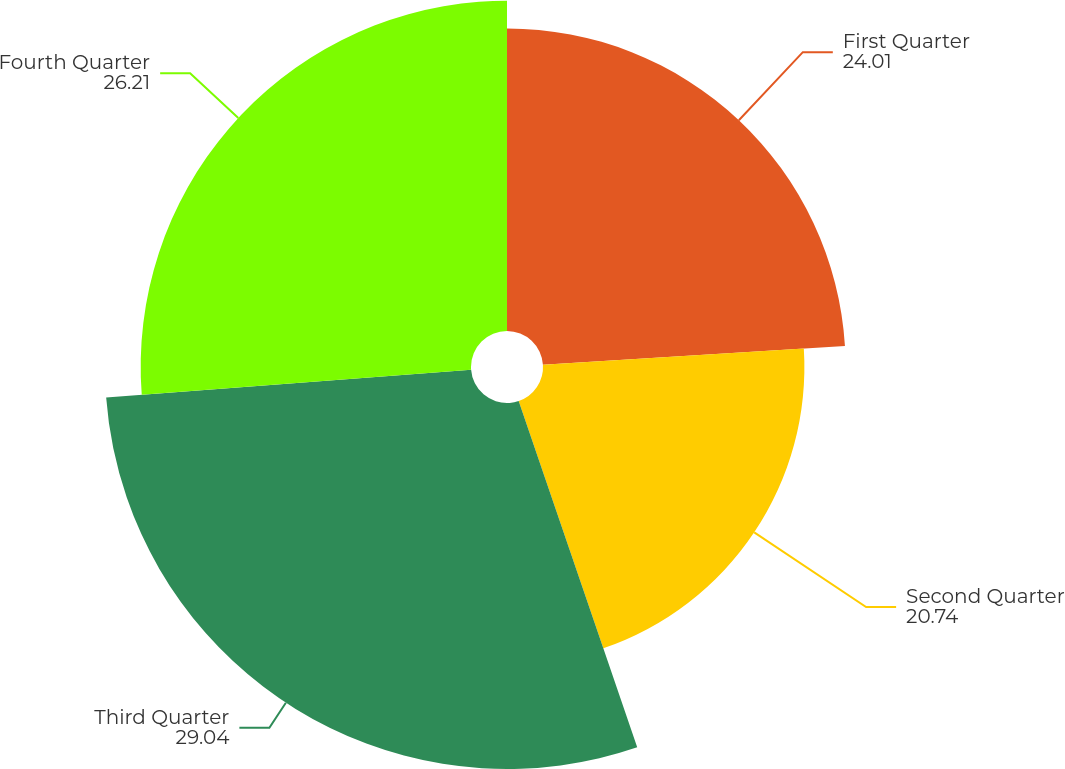Convert chart. <chart><loc_0><loc_0><loc_500><loc_500><pie_chart><fcel>First Quarter<fcel>Second Quarter<fcel>Third Quarter<fcel>Fourth Quarter<nl><fcel>24.01%<fcel>20.74%<fcel>29.04%<fcel>26.21%<nl></chart> 